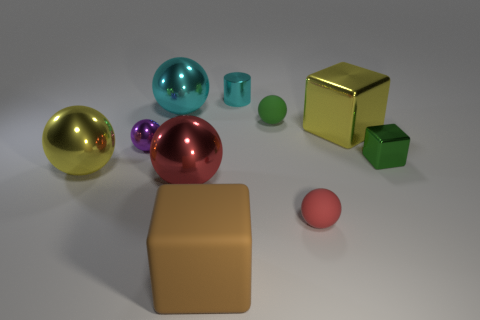Subtract all cyan balls. How many balls are left? 5 Subtract 3 balls. How many balls are left? 3 Subtract all yellow spheres. How many spheres are left? 5 Subtract all gray spheres. Subtract all red cylinders. How many spheres are left? 6 Subtract all cubes. How many objects are left? 7 Subtract all blocks. Subtract all cyan spheres. How many objects are left? 6 Add 2 big red balls. How many big red balls are left? 3 Add 5 cyan things. How many cyan things exist? 7 Subtract 0 blue blocks. How many objects are left? 10 